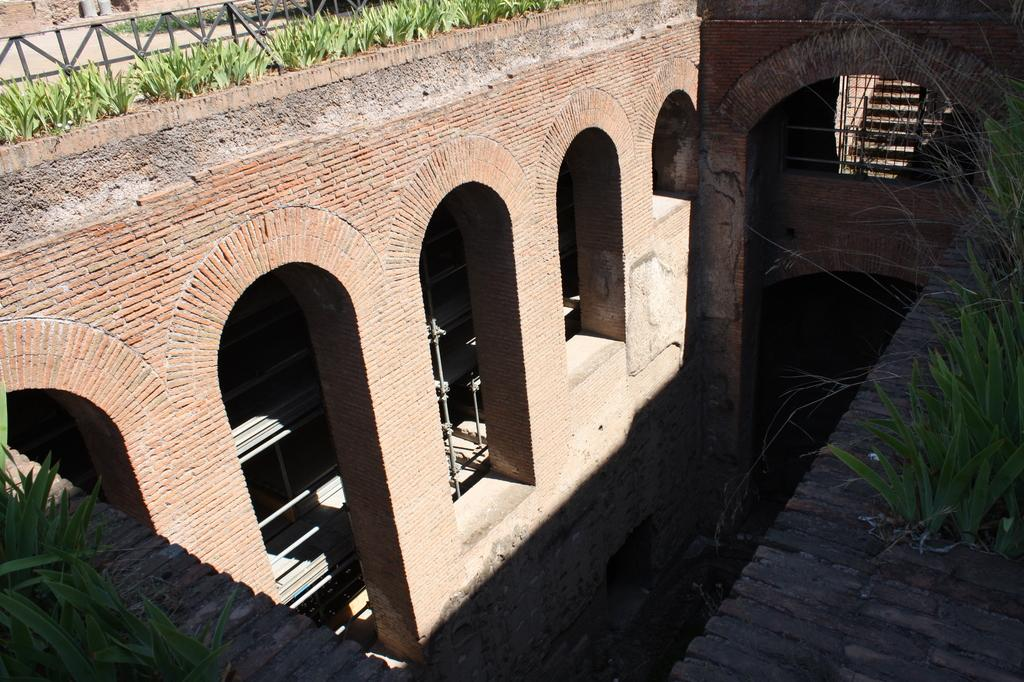What type of structures can be seen in the image? There are buildings in the image. What are the rods used for in the image? The purpose of the rods in the image is not specified, but they are visible. What architectural feature is present in the image? There are steps in the image. What type of barrier is present in the image? There is a fence in the image. What type of natural elements can be seen in the image? There are plants in the image. What type of music can be heard coming from the trees in the image? There are no trees or music present in the image. What type of dish is the cook preparing in the image? There is no cook or dish preparation present in the image. 